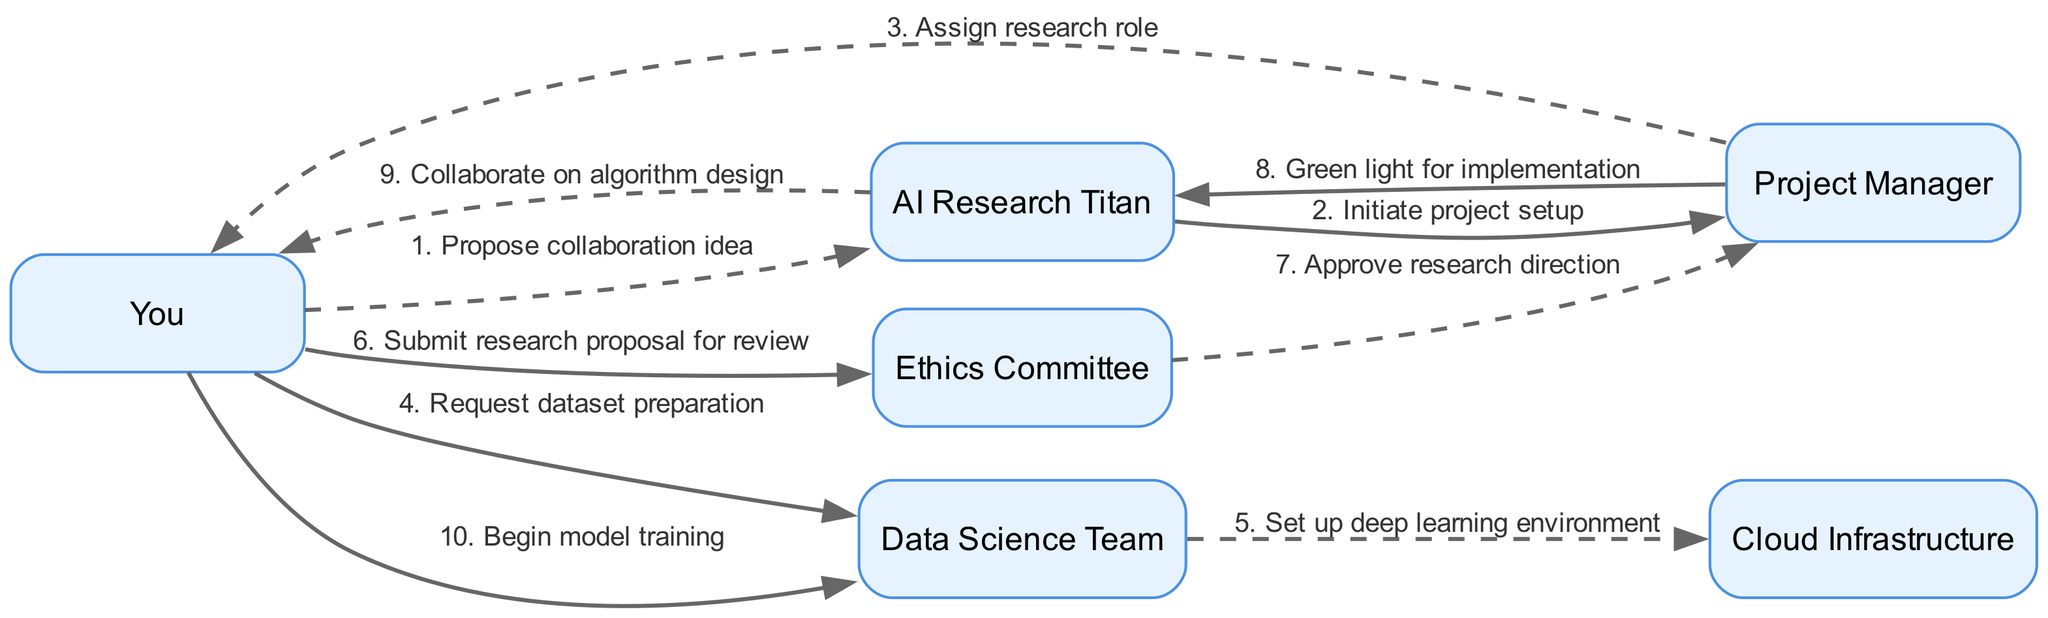What's the total number of participants in the diagram? The diagram lists six participants: You, AI Research Titan, Project Manager, Data Science Team, Ethics Committee, and Cloud Infrastructure. Counting them gives a total of six participants.
Answer: 6 Who initiates the project setup? According to the diagram, the AI Research Titan is the one who initiates the project setup, as shown in the second message exchange.
Answer: AI Research Titan What is the message sent from the Project Manager to You? The Project Manager sends the message "Assign research role" to You, which is indicated in the third step of the sequence.
Answer: Assign research role How many messages are sent before the Ethics Committee approves the research direction? The sequence shows that the Ethics Committee approves the research direction after receiving a proposal from You and before the Project Manager gives the green light. There are five messages exchanged before this occurs.
Answer: 5 Describe the relationship between the Data Science Team and the Cloud Infrastructure. The relationship is a direct work exchange, where the Data Science Team sends the message "Set up deep learning environment" to Cloud Infrastructure, indicating a collaboration to prepare resources for the project.
Answer: Set up deep learning environment What is the last action taken in the workflow? The last action in the workflow is "Begin model training," which is the final message from You to the Data Science Team. This is the concluding step in the collaboration sequence.
Answer: Begin model training Who collaborates with You on algorithm design? The AI Research Titan collaborates with You on algorithm design, as shown in the ninth message from the AI Research Titan to You.
Answer: AI Research Titan What type of message style is used when You send "Submit research proposal for review"? The message style for this action is dashed, as indicated in the diagram's sequence. The alternating message styles alternate between dashed and solid throughout the diagram.
Answer: Dashed Which committee reviews the research proposal? The Ethics Committee is responsible for reviewing the research proposal, as shown in the message flow from You to the Ethics Committee.
Answer: Ethics Committee 